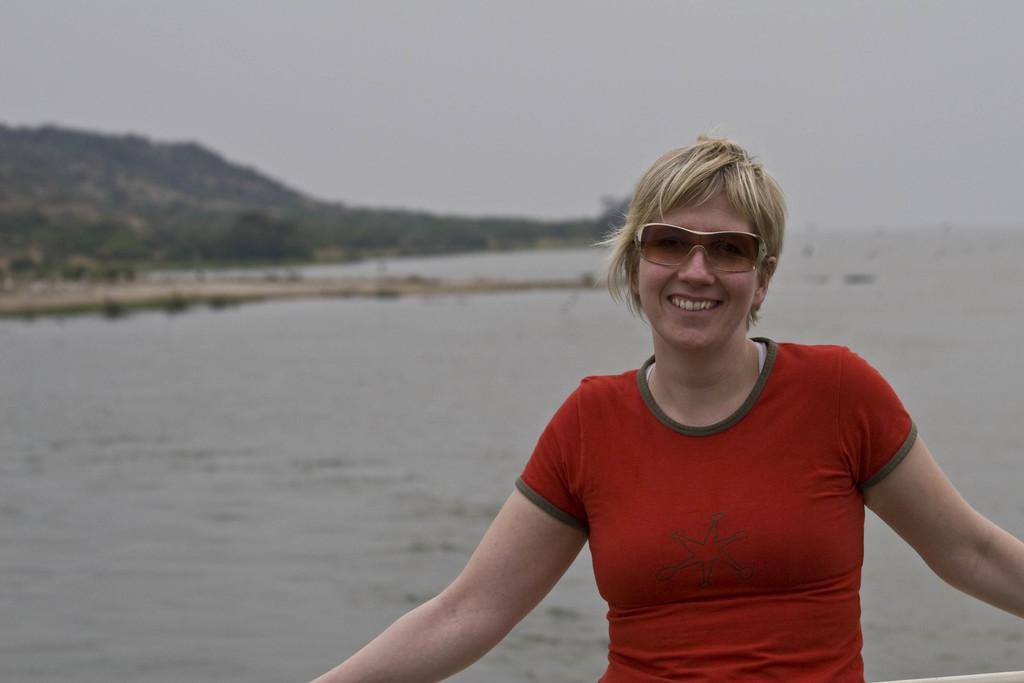What is the main subject in the image? There is a woman standing in the image. What natural features can be seen in the image? There is a large water body, a group of trees, and mountains visible in the image. What part of the sky is visible in the image? The sky is visible in the image. How many rabbits can be seen in the image? There are no rabbits present in the image. What type of comb is the woman using in the image? There is no comb visible in the image. 